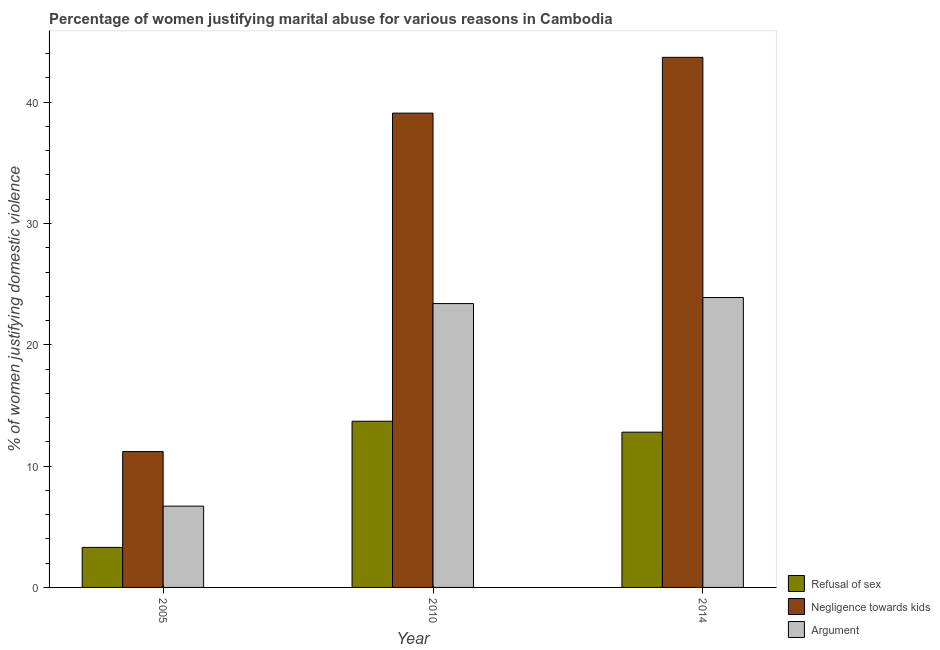How many groups of bars are there?
Offer a terse response. 3. Are the number of bars per tick equal to the number of legend labels?
Keep it short and to the point. Yes. Are the number of bars on each tick of the X-axis equal?
Make the answer very short. Yes. How many bars are there on the 3rd tick from the left?
Make the answer very short. 3. How many bars are there on the 1st tick from the right?
Provide a succinct answer. 3. In how many cases, is the number of bars for a given year not equal to the number of legend labels?
Provide a succinct answer. 0. What is the percentage of women justifying domestic violence due to refusal of sex in 2005?
Your answer should be very brief. 3.3. Across all years, what is the maximum percentage of women justifying domestic violence due to refusal of sex?
Offer a terse response. 13.7. Across all years, what is the minimum percentage of women justifying domestic violence due to refusal of sex?
Give a very brief answer. 3.3. What is the total percentage of women justifying domestic violence due to negligence towards kids in the graph?
Your answer should be very brief. 94. What is the difference between the percentage of women justifying domestic violence due to negligence towards kids in 2005 and that in 2014?
Your answer should be compact. -32.5. What is the average percentage of women justifying domestic violence due to refusal of sex per year?
Make the answer very short. 9.93. In the year 2014, what is the difference between the percentage of women justifying domestic violence due to refusal of sex and percentage of women justifying domestic violence due to negligence towards kids?
Give a very brief answer. 0. What is the ratio of the percentage of women justifying domestic violence due to refusal of sex in 2010 to that in 2014?
Ensure brevity in your answer.  1.07. Is the percentage of women justifying domestic violence due to arguments in 2005 less than that in 2010?
Offer a very short reply. Yes. What is the difference between the highest and the lowest percentage of women justifying domestic violence due to refusal of sex?
Keep it short and to the point. 10.4. In how many years, is the percentage of women justifying domestic violence due to negligence towards kids greater than the average percentage of women justifying domestic violence due to negligence towards kids taken over all years?
Provide a succinct answer. 2. What does the 2nd bar from the left in 2005 represents?
Offer a very short reply. Negligence towards kids. What does the 3rd bar from the right in 2005 represents?
Your answer should be compact. Refusal of sex. Is it the case that in every year, the sum of the percentage of women justifying domestic violence due to refusal of sex and percentage of women justifying domestic violence due to negligence towards kids is greater than the percentage of women justifying domestic violence due to arguments?
Give a very brief answer. Yes. How many years are there in the graph?
Provide a short and direct response. 3. What is the difference between two consecutive major ticks on the Y-axis?
Offer a very short reply. 10. Does the graph contain any zero values?
Offer a very short reply. No. Where does the legend appear in the graph?
Keep it short and to the point. Bottom right. How many legend labels are there?
Your answer should be compact. 3. How are the legend labels stacked?
Ensure brevity in your answer.  Vertical. What is the title of the graph?
Provide a succinct answer. Percentage of women justifying marital abuse for various reasons in Cambodia. What is the label or title of the Y-axis?
Make the answer very short. % of women justifying domestic violence. What is the % of women justifying domestic violence of Refusal of sex in 2005?
Offer a very short reply. 3.3. What is the % of women justifying domestic violence of Refusal of sex in 2010?
Keep it short and to the point. 13.7. What is the % of women justifying domestic violence of Negligence towards kids in 2010?
Provide a succinct answer. 39.1. What is the % of women justifying domestic violence in Argument in 2010?
Keep it short and to the point. 23.4. What is the % of women justifying domestic violence in Refusal of sex in 2014?
Provide a short and direct response. 12.8. What is the % of women justifying domestic violence in Negligence towards kids in 2014?
Your answer should be compact. 43.7. What is the % of women justifying domestic violence in Argument in 2014?
Your answer should be compact. 23.9. Across all years, what is the maximum % of women justifying domestic violence in Negligence towards kids?
Your answer should be compact. 43.7. Across all years, what is the maximum % of women justifying domestic violence in Argument?
Your response must be concise. 23.9. Across all years, what is the minimum % of women justifying domestic violence in Negligence towards kids?
Offer a very short reply. 11.2. Across all years, what is the minimum % of women justifying domestic violence in Argument?
Your answer should be very brief. 6.7. What is the total % of women justifying domestic violence of Refusal of sex in the graph?
Make the answer very short. 29.8. What is the total % of women justifying domestic violence in Negligence towards kids in the graph?
Provide a short and direct response. 94. What is the difference between the % of women justifying domestic violence in Negligence towards kids in 2005 and that in 2010?
Make the answer very short. -27.9. What is the difference between the % of women justifying domestic violence of Argument in 2005 and that in 2010?
Your response must be concise. -16.7. What is the difference between the % of women justifying domestic violence of Negligence towards kids in 2005 and that in 2014?
Offer a very short reply. -32.5. What is the difference between the % of women justifying domestic violence in Argument in 2005 and that in 2014?
Provide a short and direct response. -17.2. What is the difference between the % of women justifying domestic violence of Refusal of sex in 2010 and that in 2014?
Ensure brevity in your answer.  0.9. What is the difference between the % of women justifying domestic violence of Argument in 2010 and that in 2014?
Give a very brief answer. -0.5. What is the difference between the % of women justifying domestic violence of Refusal of sex in 2005 and the % of women justifying domestic violence of Negligence towards kids in 2010?
Give a very brief answer. -35.8. What is the difference between the % of women justifying domestic violence of Refusal of sex in 2005 and the % of women justifying domestic violence of Argument in 2010?
Provide a succinct answer. -20.1. What is the difference between the % of women justifying domestic violence in Refusal of sex in 2005 and the % of women justifying domestic violence in Negligence towards kids in 2014?
Provide a succinct answer. -40.4. What is the difference between the % of women justifying domestic violence of Refusal of sex in 2005 and the % of women justifying domestic violence of Argument in 2014?
Provide a succinct answer. -20.6. What is the difference between the % of women justifying domestic violence of Negligence towards kids in 2005 and the % of women justifying domestic violence of Argument in 2014?
Your answer should be compact. -12.7. What is the difference between the % of women justifying domestic violence in Refusal of sex in 2010 and the % of women justifying domestic violence in Negligence towards kids in 2014?
Your answer should be very brief. -30. What is the average % of women justifying domestic violence in Refusal of sex per year?
Provide a short and direct response. 9.93. What is the average % of women justifying domestic violence of Negligence towards kids per year?
Provide a succinct answer. 31.33. What is the average % of women justifying domestic violence in Argument per year?
Ensure brevity in your answer.  18. In the year 2005, what is the difference between the % of women justifying domestic violence in Refusal of sex and % of women justifying domestic violence in Negligence towards kids?
Keep it short and to the point. -7.9. In the year 2010, what is the difference between the % of women justifying domestic violence in Refusal of sex and % of women justifying domestic violence in Negligence towards kids?
Offer a very short reply. -25.4. In the year 2010, what is the difference between the % of women justifying domestic violence of Refusal of sex and % of women justifying domestic violence of Argument?
Give a very brief answer. -9.7. In the year 2010, what is the difference between the % of women justifying domestic violence of Negligence towards kids and % of women justifying domestic violence of Argument?
Provide a short and direct response. 15.7. In the year 2014, what is the difference between the % of women justifying domestic violence in Refusal of sex and % of women justifying domestic violence in Negligence towards kids?
Keep it short and to the point. -30.9. In the year 2014, what is the difference between the % of women justifying domestic violence in Refusal of sex and % of women justifying domestic violence in Argument?
Make the answer very short. -11.1. In the year 2014, what is the difference between the % of women justifying domestic violence of Negligence towards kids and % of women justifying domestic violence of Argument?
Your answer should be very brief. 19.8. What is the ratio of the % of women justifying domestic violence in Refusal of sex in 2005 to that in 2010?
Your answer should be compact. 0.24. What is the ratio of the % of women justifying domestic violence of Negligence towards kids in 2005 to that in 2010?
Offer a very short reply. 0.29. What is the ratio of the % of women justifying domestic violence in Argument in 2005 to that in 2010?
Your answer should be very brief. 0.29. What is the ratio of the % of women justifying domestic violence in Refusal of sex in 2005 to that in 2014?
Your answer should be compact. 0.26. What is the ratio of the % of women justifying domestic violence of Negligence towards kids in 2005 to that in 2014?
Ensure brevity in your answer.  0.26. What is the ratio of the % of women justifying domestic violence in Argument in 2005 to that in 2014?
Make the answer very short. 0.28. What is the ratio of the % of women justifying domestic violence in Refusal of sex in 2010 to that in 2014?
Your answer should be compact. 1.07. What is the ratio of the % of women justifying domestic violence in Negligence towards kids in 2010 to that in 2014?
Ensure brevity in your answer.  0.89. What is the ratio of the % of women justifying domestic violence of Argument in 2010 to that in 2014?
Your response must be concise. 0.98. What is the difference between the highest and the second highest % of women justifying domestic violence of Negligence towards kids?
Your answer should be very brief. 4.6. What is the difference between the highest and the lowest % of women justifying domestic violence in Refusal of sex?
Your answer should be very brief. 10.4. What is the difference between the highest and the lowest % of women justifying domestic violence in Negligence towards kids?
Your answer should be compact. 32.5. 